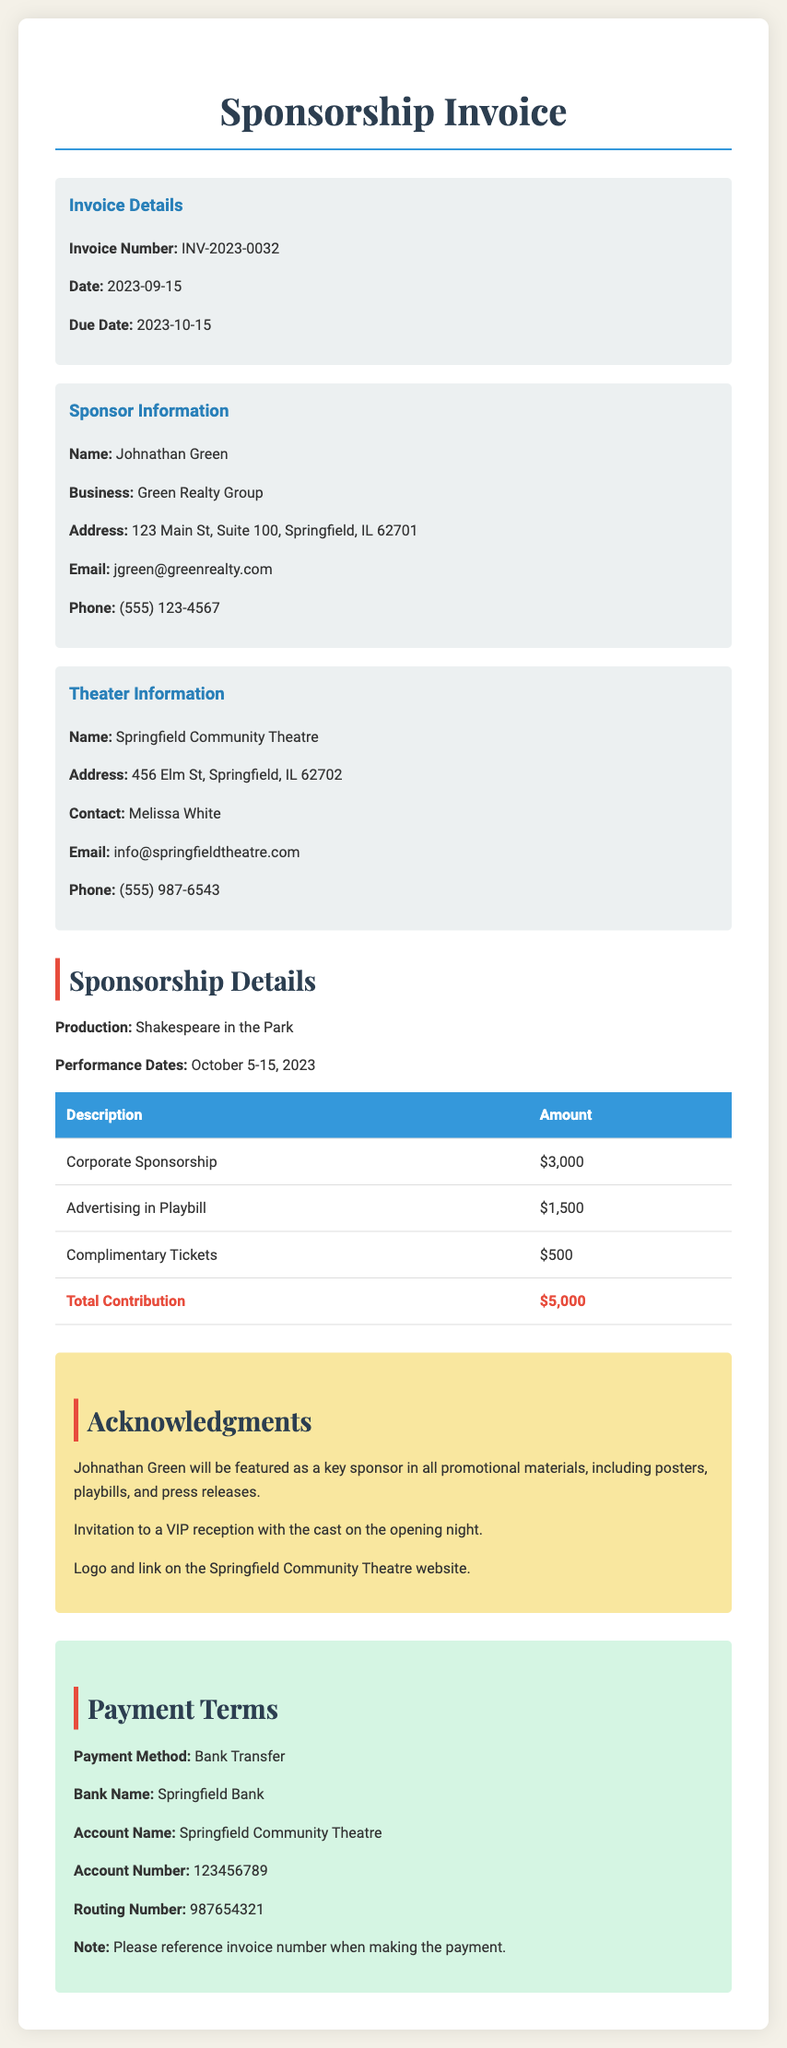what is the invoice number? The invoice number is identified in the document for reference and tracking, which is INV-2023-0032.
Answer: INV-2023-0032 who is the sponsor? The document specifies the name of the sponsor who provided financial support, which is Johnathan Green.
Answer: Johnathan Green what is the total contribution amount? The total contribution is summarized at the end of the cost details as the sum of all listed amounts, which is $5,000.
Answer: $5,000 when is the due date for payment? The due date is stated in the invoice details section, which is an essential piece of information for ensuring timely payment.
Answer: 2023-10-15 what is the name of the production being sponsored? The production name is mentioned explicitly in the sponsorship details section, indicating the artistic event supported by the sponsor.
Answer: Shakespeare in the Park how much is allocated for advertising in Playbill? This information specifies the cost associated with advertising, which is necessary for budget understanding, mentioned as $1,500.
Answer: $1,500 how will Johnathan Green be acknowledged? The document outlines specific ways Johnathan Green's contribution will be recognized, including promotional materials, receptions, and website acknowledgment.
Answer: Featured as a key sponsor what payment method is required for this sponsorship? The payment terms clarify how the sponsorship payment should be processed, indicating a direct instruction for transaction.
Answer: Bank Transfer who is the contact person at the theater? The document lists a contact person at the theater for communication regarding the sponsorship, which is crucial for follow-up or inquiries.
Answer: Melissa White 